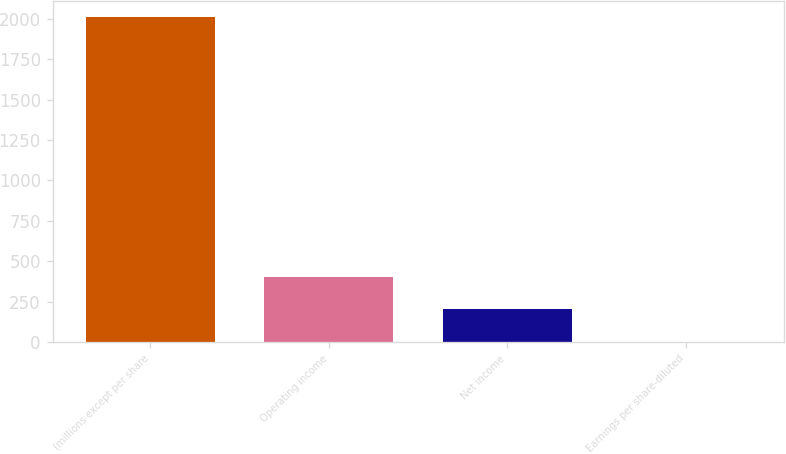<chart> <loc_0><loc_0><loc_500><loc_500><bar_chart><fcel>(millions except per share<fcel>Operating income<fcel>Net income<fcel>Earnings per share-diluted<nl><fcel>2013<fcel>402.78<fcel>201.5<fcel>0.22<nl></chart> 